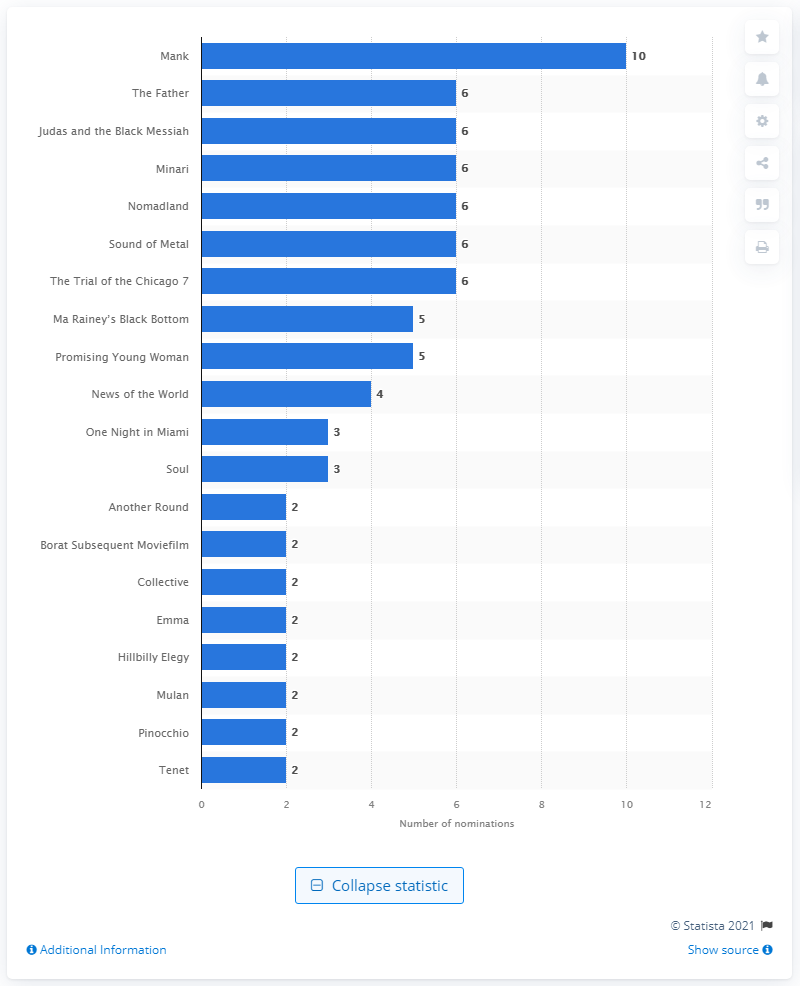Indicate a few pertinent items in this graphic. In 2021, the movie 'Mank' received the most Oscar nominations. 